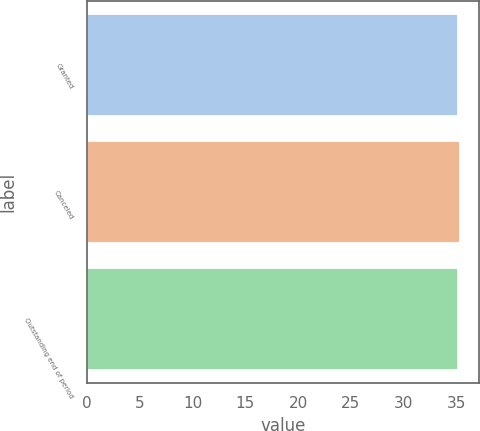<chart> <loc_0><loc_0><loc_500><loc_500><bar_chart><fcel>Granted<fcel>Canceled<fcel>Outstanding end of period<nl><fcel>35.12<fcel>35.38<fcel>35.15<nl></chart> 